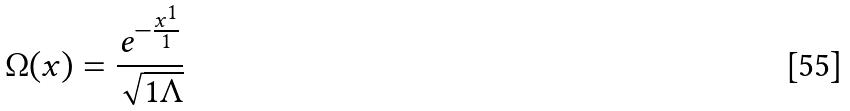<formula> <loc_0><loc_0><loc_500><loc_500>\Omega ( x ) = \frac { e ^ { - \frac { x ^ { 1 } } { 1 } } } { \sqrt { 1 \Lambda } }</formula> 